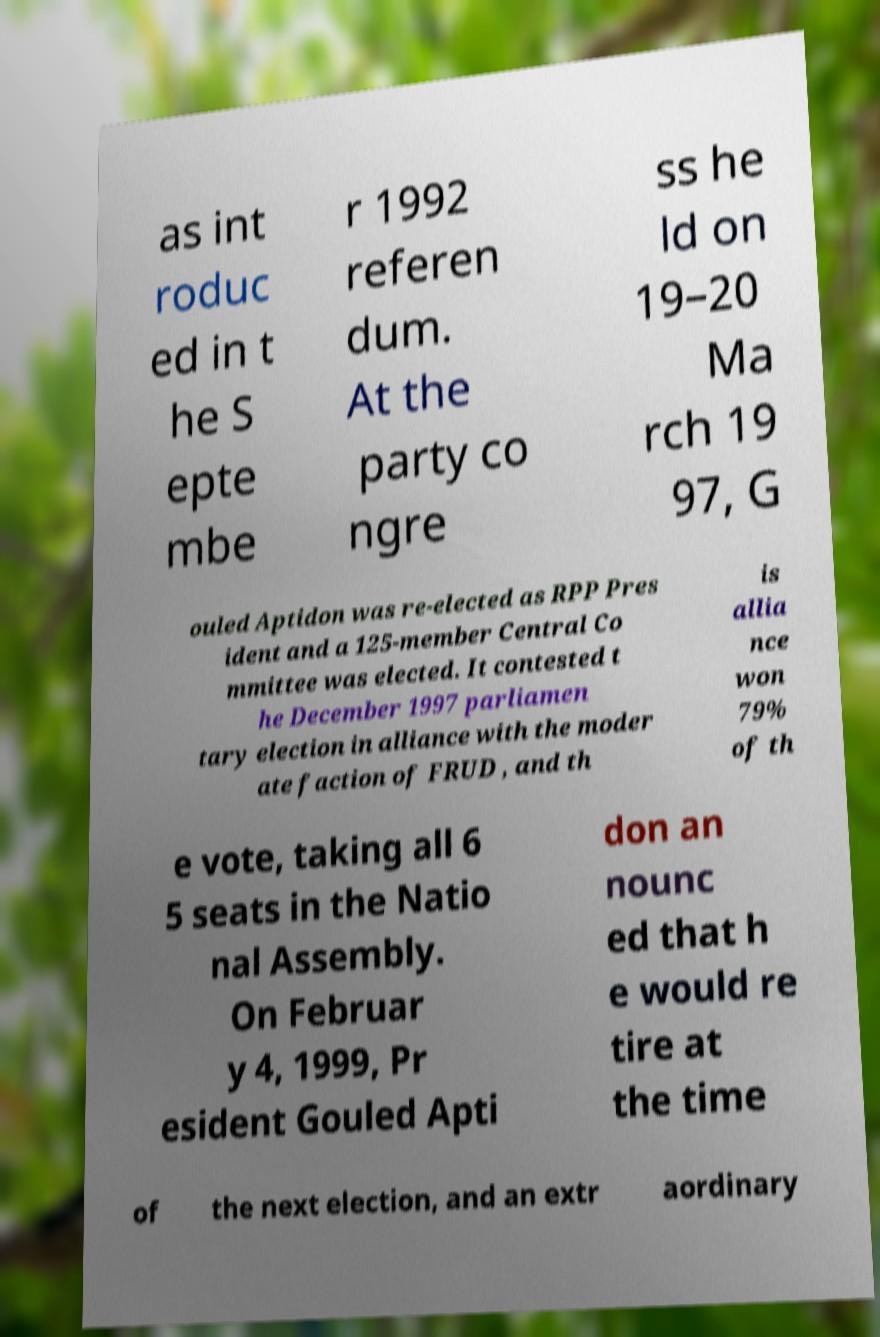Please read and relay the text visible in this image. What does it say? as int roduc ed in t he S epte mbe r 1992 referen dum. At the party co ngre ss he ld on 19–20 Ma rch 19 97, G ouled Aptidon was re-elected as RPP Pres ident and a 125-member Central Co mmittee was elected. It contested t he December 1997 parliamen tary election in alliance with the moder ate faction of FRUD , and th is allia nce won 79% of th e vote, taking all 6 5 seats in the Natio nal Assembly. On Februar y 4, 1999, Pr esident Gouled Apti don an nounc ed that h e would re tire at the time of the next election, and an extr aordinary 